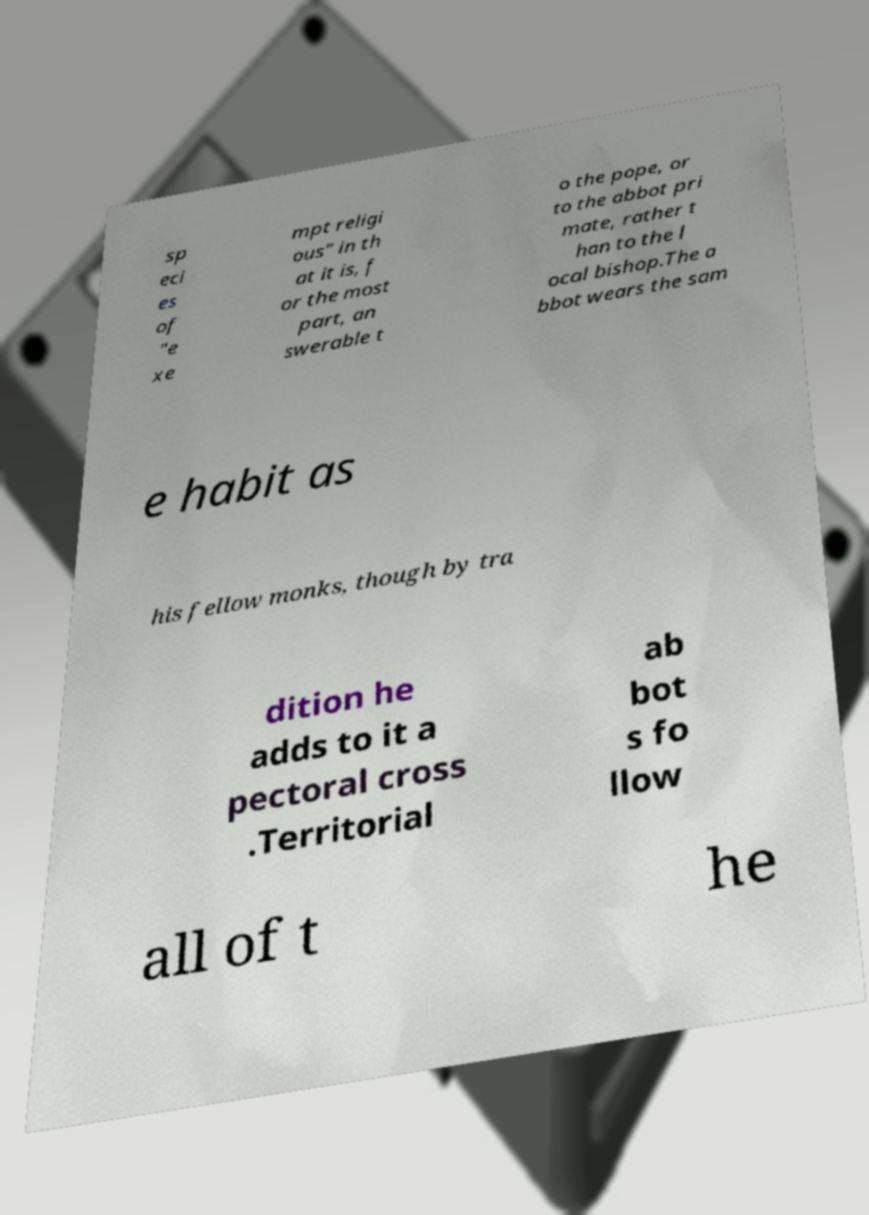Could you extract and type out the text from this image? sp eci es of "e xe mpt religi ous" in th at it is, f or the most part, an swerable t o the pope, or to the abbot pri mate, rather t han to the l ocal bishop.The a bbot wears the sam e habit as his fellow monks, though by tra dition he adds to it a pectoral cross .Territorial ab bot s fo llow all of t he 